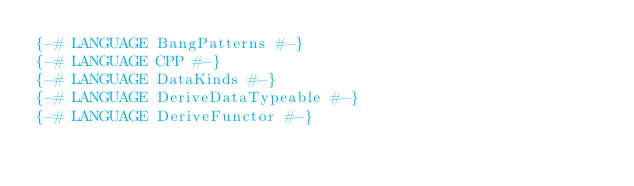Convert code to text. <code><loc_0><loc_0><loc_500><loc_500><_Haskell_>{-# LANGUAGE BangPatterns #-}
{-# LANGUAGE CPP #-}
{-# LANGUAGE DataKinds #-}
{-# LANGUAGE DeriveDataTypeable #-}
{-# LANGUAGE DeriveFunctor #-}</code> 